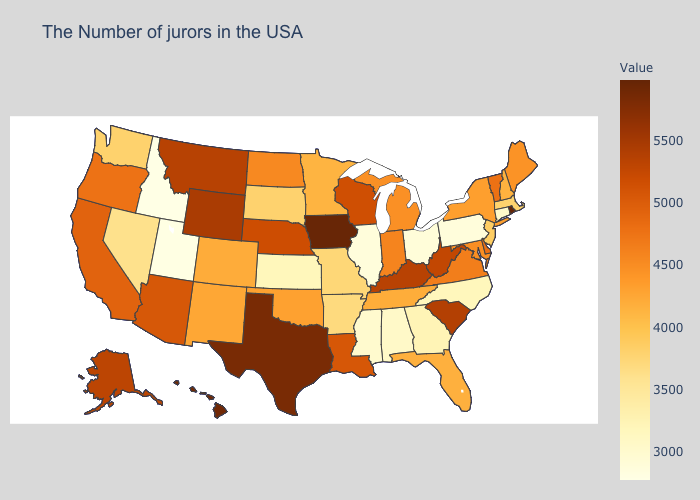Does Tennessee have a higher value than Vermont?
Be succinct. No. Does Rhode Island have the highest value in the USA?
Answer briefly. Yes. Does the map have missing data?
Concise answer only. No. Which states have the highest value in the USA?
Be succinct. Rhode Island. 